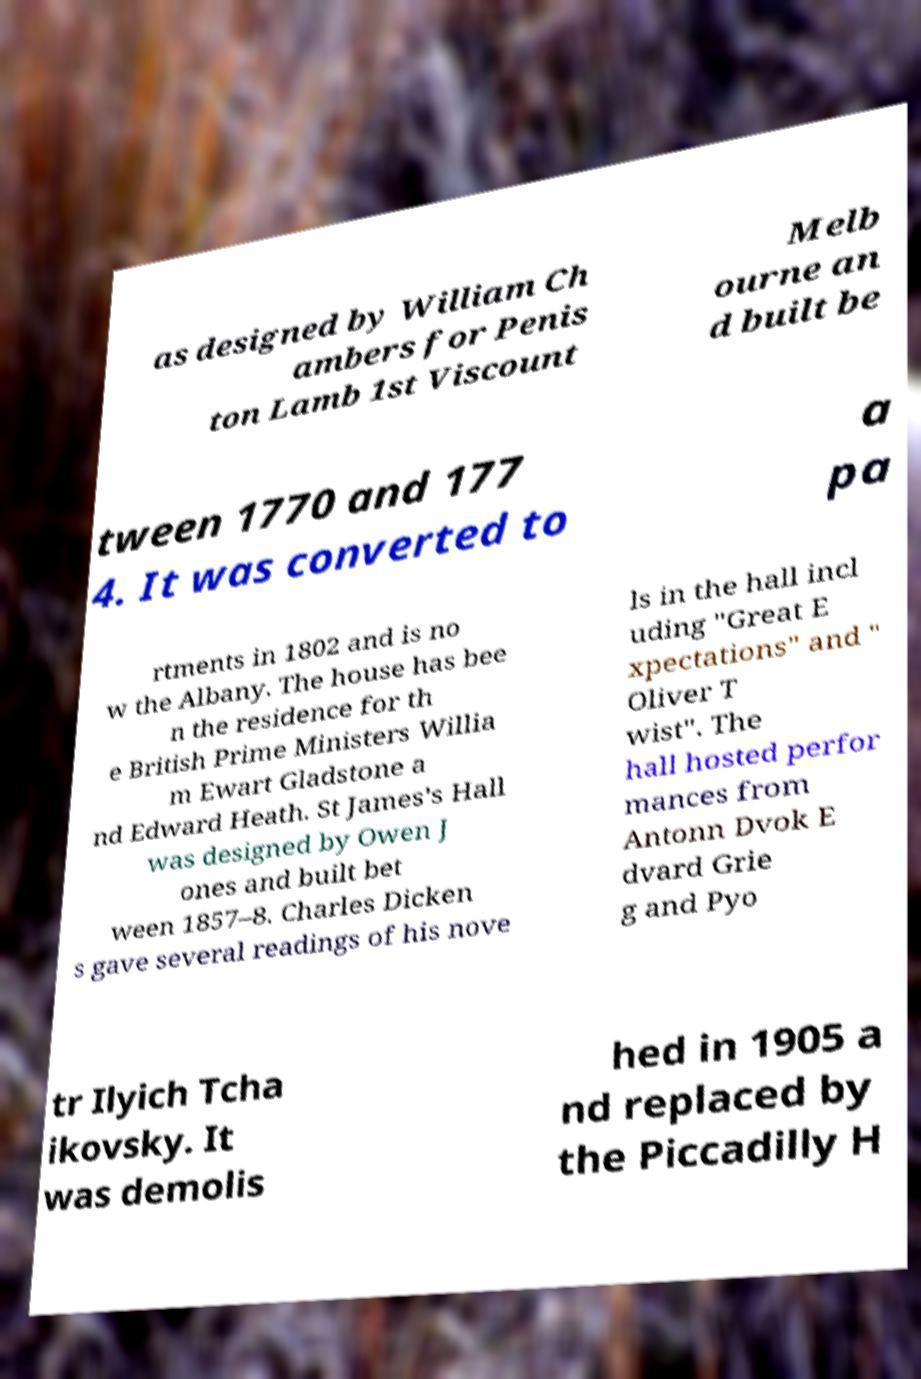I need the written content from this picture converted into text. Can you do that? as designed by William Ch ambers for Penis ton Lamb 1st Viscount Melb ourne an d built be tween 1770 and 177 4. It was converted to a pa rtments in 1802 and is no w the Albany. The house has bee n the residence for th e British Prime Ministers Willia m Ewart Gladstone a nd Edward Heath. St James's Hall was designed by Owen J ones and built bet ween 1857–8. Charles Dicken s gave several readings of his nove ls in the hall incl uding "Great E xpectations" and " Oliver T wist". The hall hosted perfor mances from Antonn Dvok E dvard Grie g and Pyo tr Ilyich Tcha ikovsky. It was demolis hed in 1905 a nd replaced by the Piccadilly H 